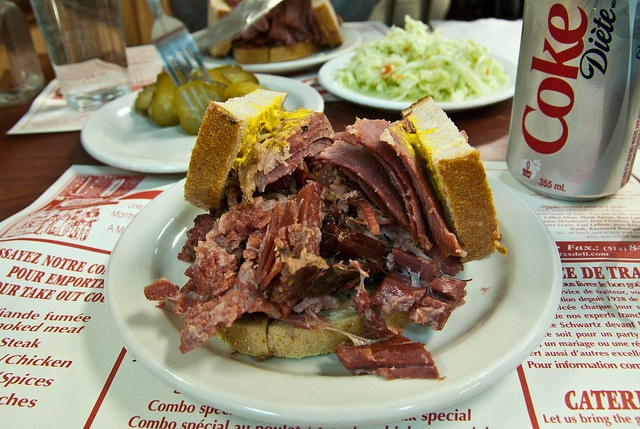Describe the objects in this image and their specific colors. I can see sandwich in gray, maroon, black, and brown tones, cup in gray, darkgray, and black tones, dining table in maroon, black, and gray tones, sandwich in gray, black, maroon, and olive tones, and fork in gray, olive, teal, and darkgray tones in this image. 